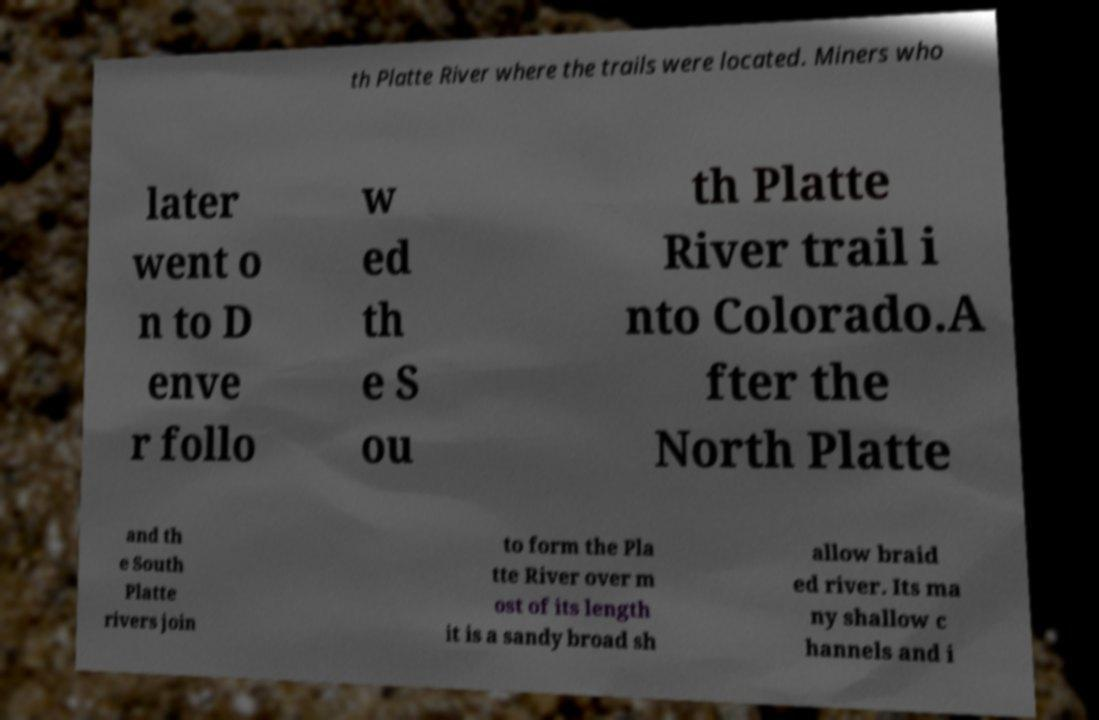Can you accurately transcribe the text from the provided image for me? th Platte River where the trails were located. Miners who later went o n to D enve r follo w ed th e S ou th Platte River trail i nto Colorado.A fter the North Platte and th e South Platte rivers join to form the Pla tte River over m ost of its length it is a sandy broad sh allow braid ed river. Its ma ny shallow c hannels and i 